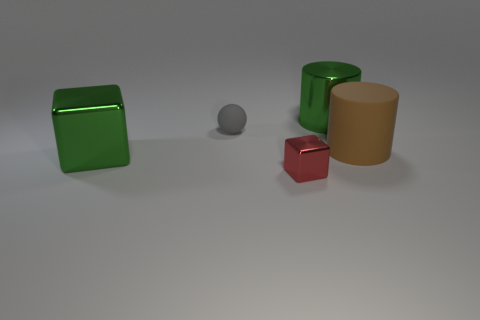The brown rubber object is what size?
Your response must be concise. Large. Is the material of the red thing the same as the brown cylinder?
Your answer should be very brief. No. There is a green shiny object left of the metal object that is right of the tiny red metallic block; what number of green metal cubes are in front of it?
Offer a terse response. 0. What is the shape of the big green metallic thing behind the rubber ball?
Keep it short and to the point. Cylinder. How many other objects are the same material as the small red object?
Offer a terse response. 2. Does the big cube have the same color as the big rubber cylinder?
Provide a short and direct response. No. Is the number of large brown cylinders behind the large brown cylinder less than the number of metallic things to the left of the tiny shiny block?
Keep it short and to the point. Yes. There is a big metallic thing that is the same shape as the brown matte object; what color is it?
Offer a terse response. Green. There is a metallic cube that is left of the rubber ball; is its size the same as the metallic cylinder?
Offer a very short reply. Yes. Are there fewer blocks that are right of the large green metal cylinder than big shiny cubes?
Provide a succinct answer. Yes. 